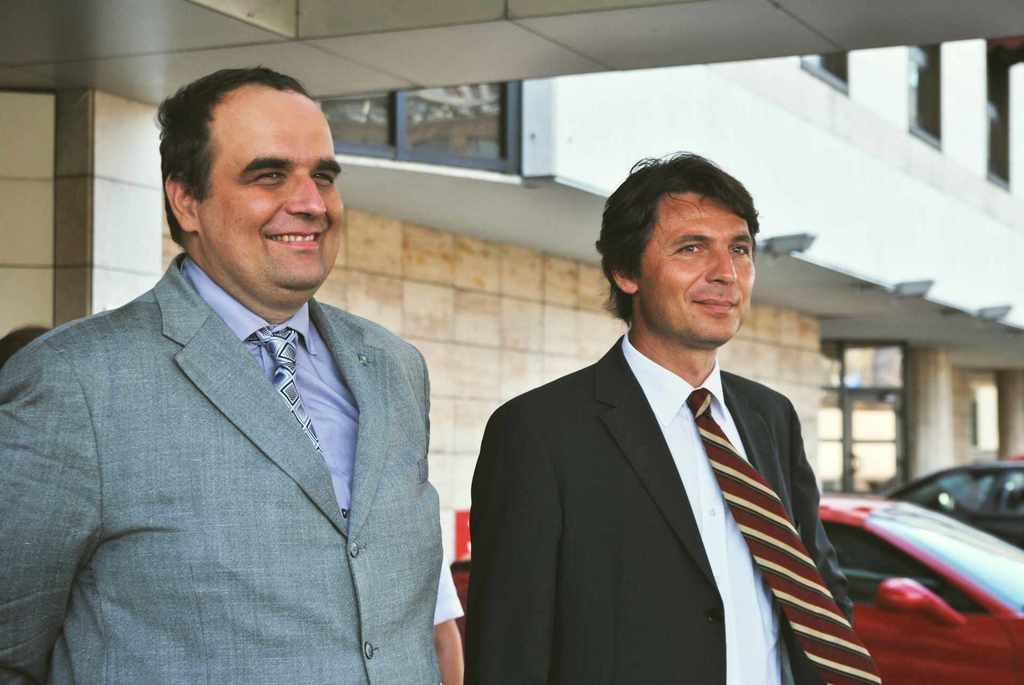How many people are in the image? There are two people in the image. What are the people wearing? Both people are wearing blazers and ties. What are the people doing in the image? The people are standing and smiling. What can be seen in the background of the image? There is a building and cars parked in the background of the image. How much string is visible in the image? There is no string present in the image. What type of bottle can be seen in the hands of the people? There are no bottles visible in the image; the people are not holding anything. 